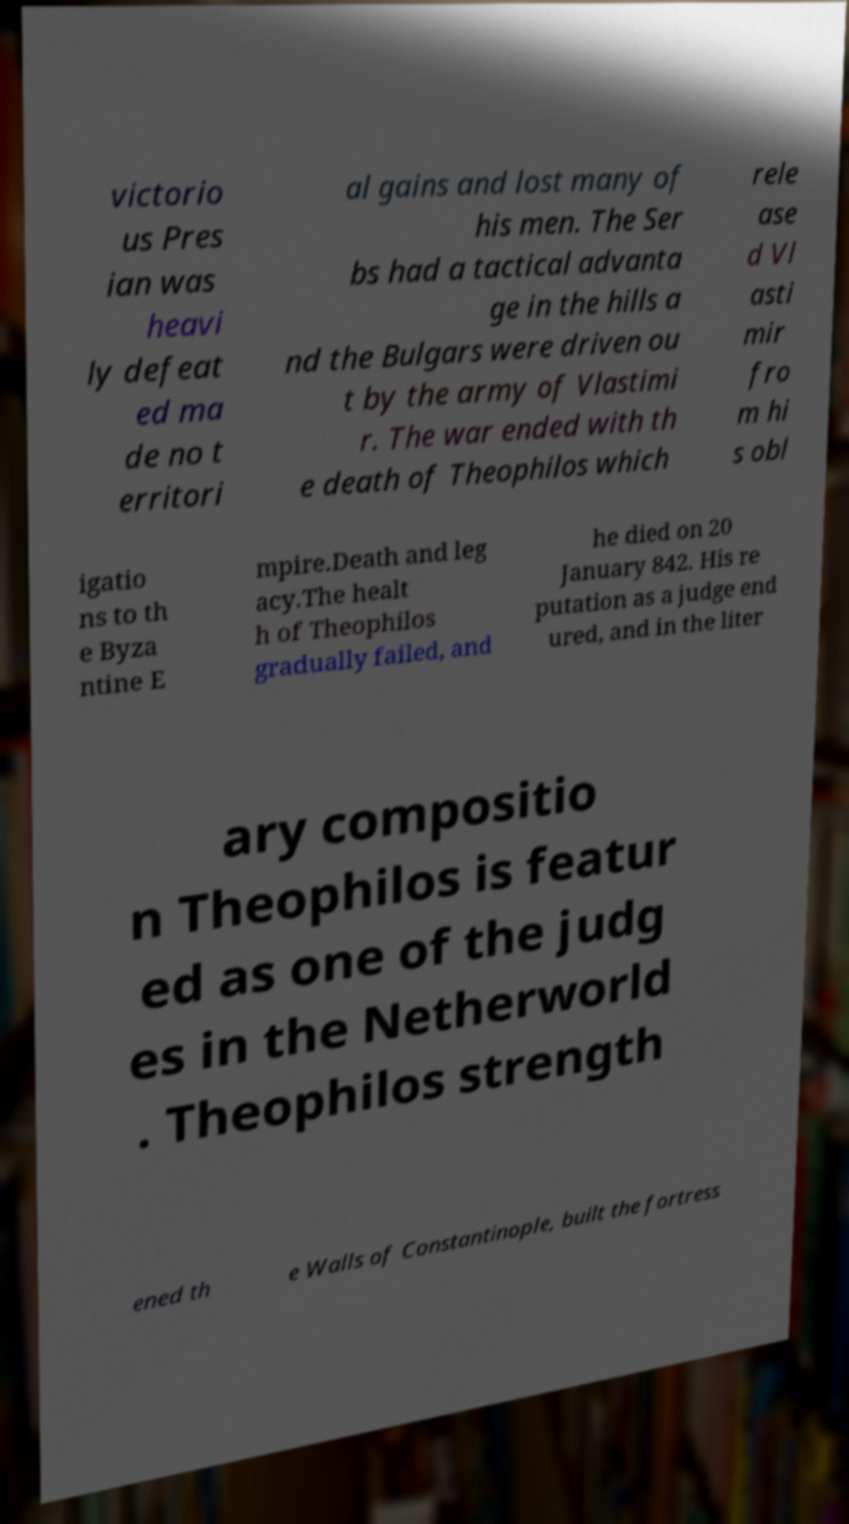Please read and relay the text visible in this image. What does it say? victorio us Pres ian was heavi ly defeat ed ma de no t erritori al gains and lost many of his men. The Ser bs had a tactical advanta ge in the hills a nd the Bulgars were driven ou t by the army of Vlastimi r. The war ended with th e death of Theophilos which rele ase d Vl asti mir fro m hi s obl igatio ns to th e Byza ntine E mpire.Death and leg acy.The healt h of Theophilos gradually failed, and he died on 20 January 842. His re putation as a judge end ured, and in the liter ary compositio n Theophilos is featur ed as one of the judg es in the Netherworld . Theophilos strength ened th e Walls of Constantinople, built the fortress 